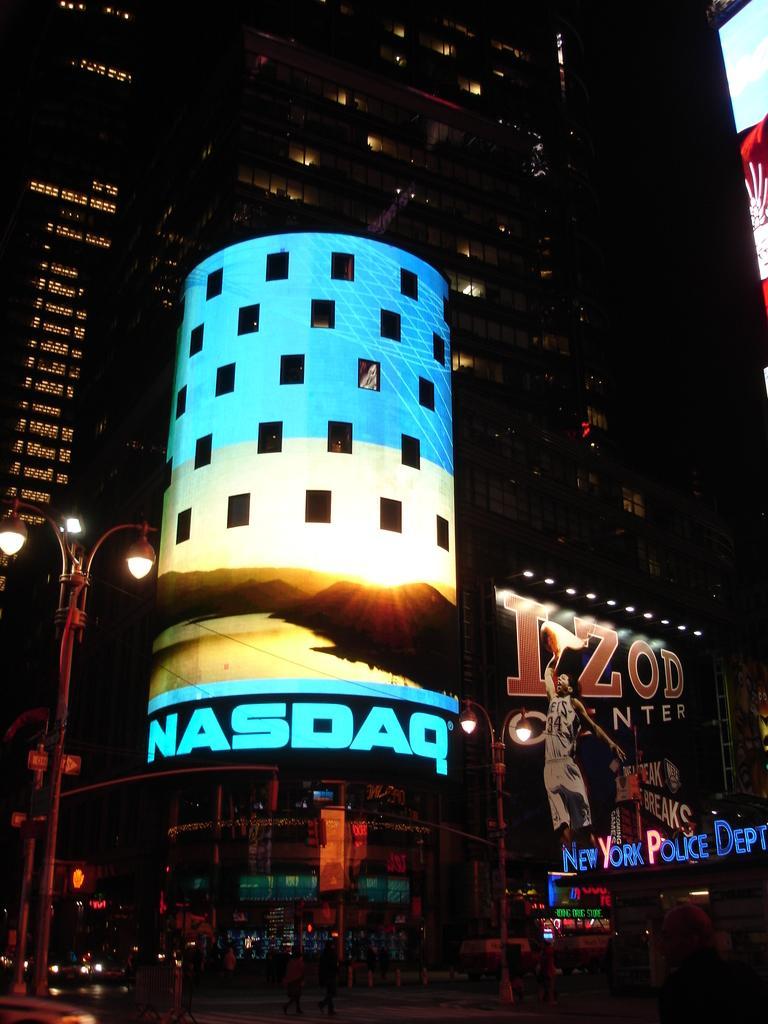Please provide a concise description of this image. In this picture we can see buildings lighted up in the dark. We have vehicles on the road & a street light on the side of the road. 